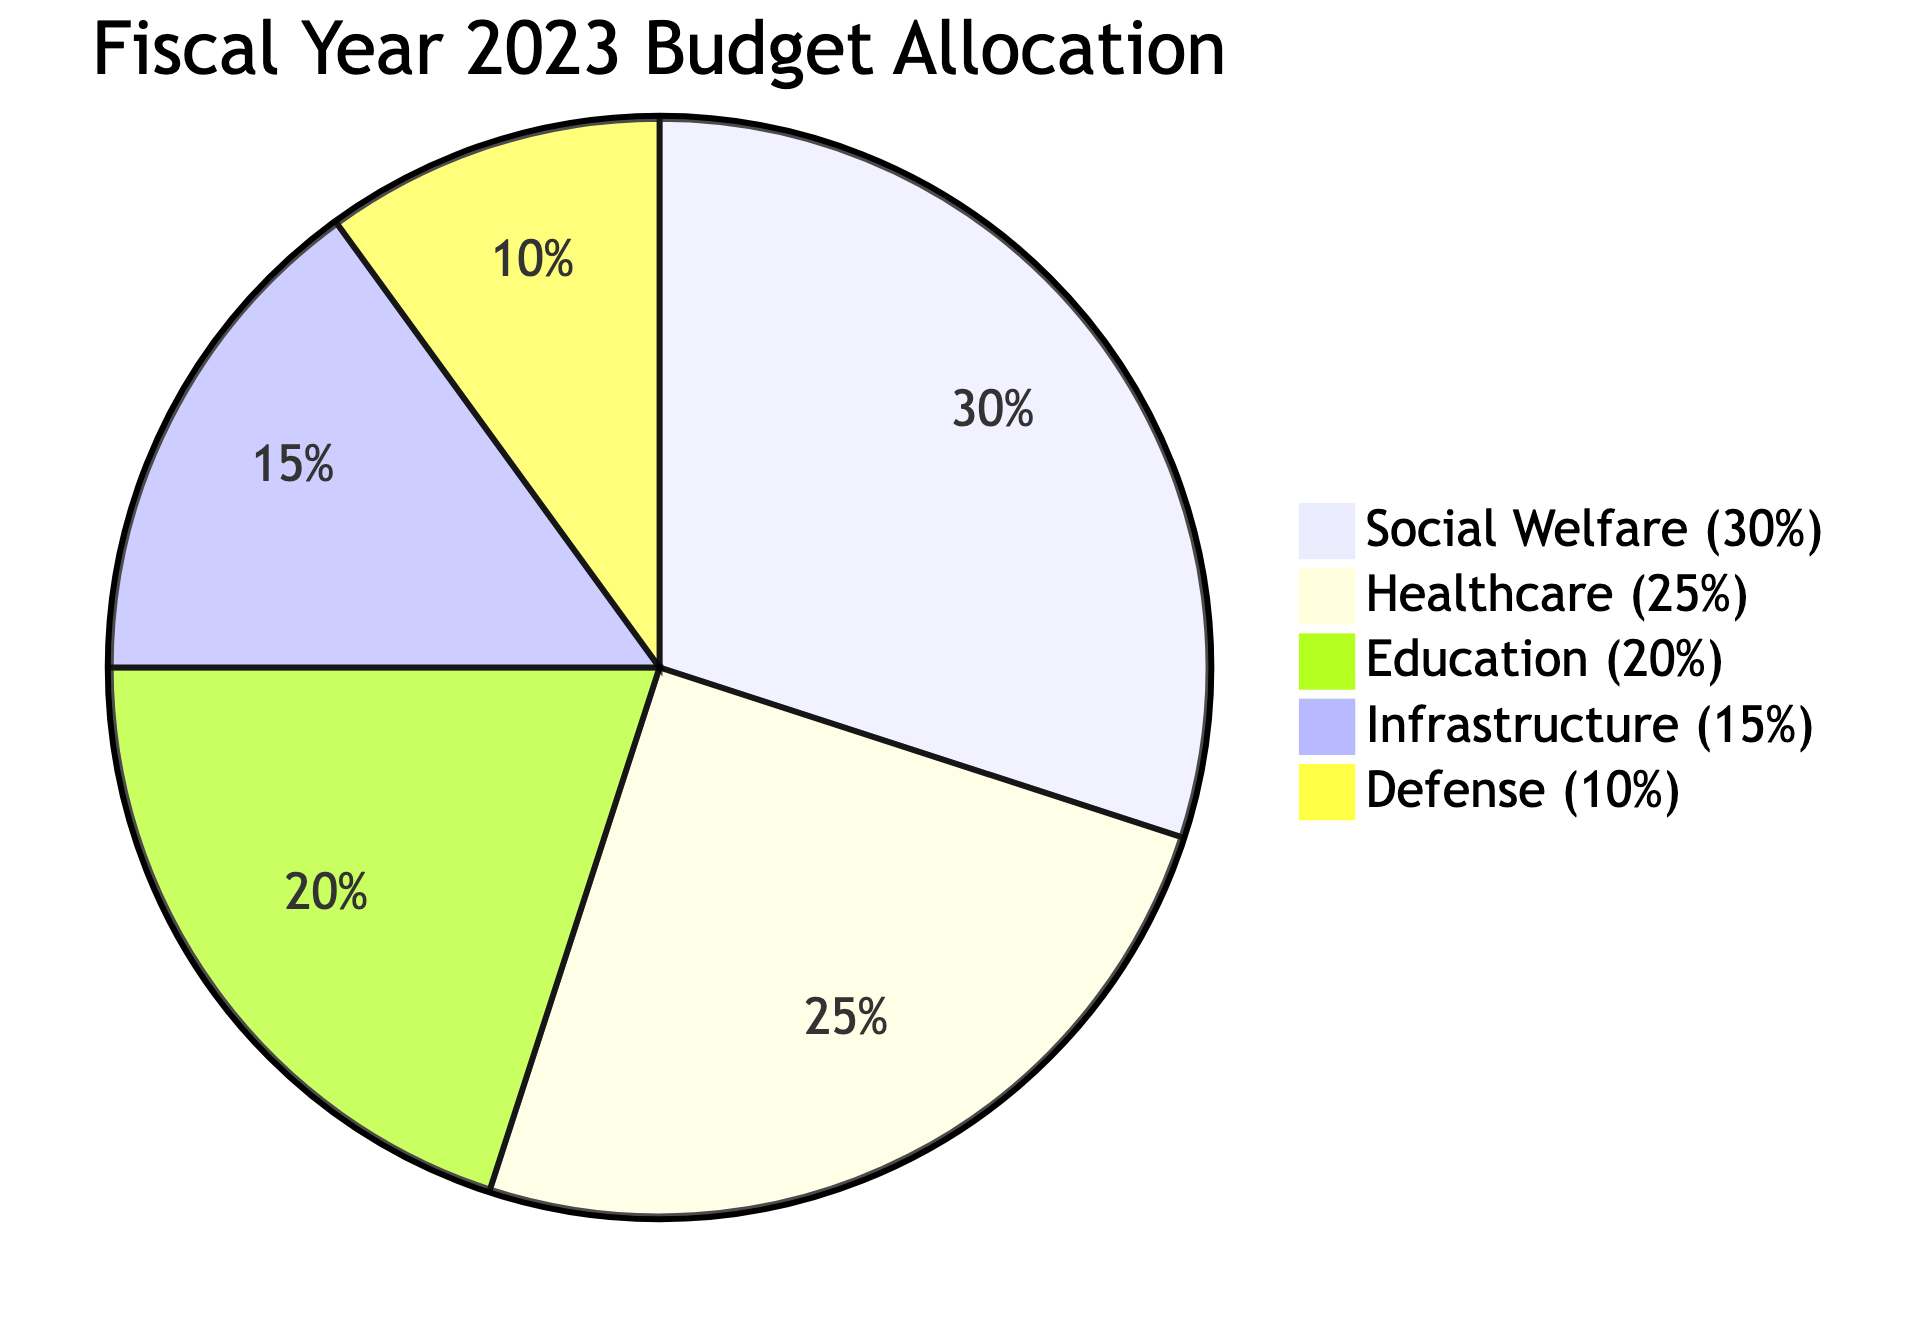What is the largest sector in the budget allocation? The largest sector can be identified by looking for the slice with the most significant percentage in the pie chart. In this case, "Social Welfare" occupies 30% of the chart, making it the largest sector.
Answer: Social Welfare How much is allocated to Healthcare? To find the allocation to Healthcare, locate the corresponding slice in the pie chart, which indicates that Healthcare is allocated 25% of the budget for the fiscal year 2023.
Answer: 25% Which sector has the smallest allocation? The sector with the smallest allocation can be identified by observing the slice that takes up the least portion of the pie chart. The "Defense" sector is the smallest, representing 10% of the budget.
Answer: Defense What is the combined percentage of Education and Infrastructure? To find the combined percentage, add the percentages of the "Education" and "Infrastructure" sectors. Education is 20% and Infrastructure is 15%, so the total is 20% + 15% = 35%.
Answer: 35% What fraction of the budget is dedicated to social sectors (Social Welfare, Healthcare, and Education)? First, identify the percentages for Social Welfare (30%), Healthcare (25%), and Education (20%). Then, add these amounts: 30% + 25% + 20% = 75%. This shows that 75% of the budget is allocated to social sectors.
Answer: 75% What percentage is allocated to Defense compared to Infrastructure? Calculate by noting the percentage of Defense (10%) and Infrastructure (15%). To compare, Defense is 10% and Infrastructure is 15%. Therefore, Defense is a smaller allocation than Infrastructure.
Answer: 10% Which two sectors together account for 45% of the budget? Identify the pairs of sectors by addition: Social Welfare (30%) + Healthcare (25%) = 55% (too high), Social Welfare (30%) + Education (20%) = 50% (too high), Healthcare (25%) + Education (20%) = 45%. Therefore, Healthcare and Education account for 45% of the budget.
Answer: Healthcare and Education 